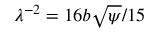<formula> <loc_0><loc_0><loc_500><loc_500>\lambda ^ { - 2 } = 1 6 b \sqrt { \psi } / 1 5</formula> 